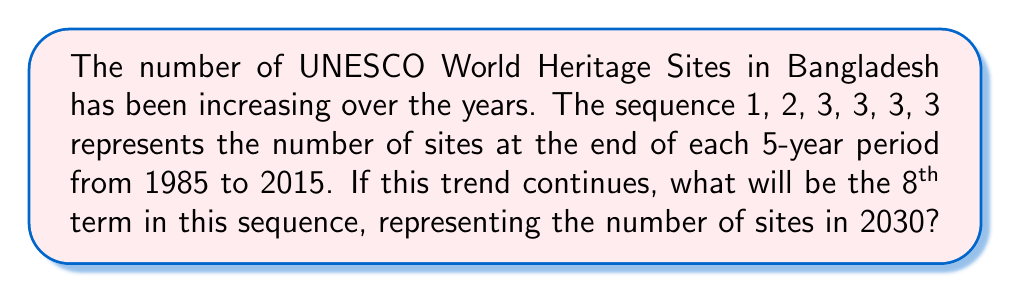Give your solution to this math problem. Let's analyze the sequence step-by-step:

1) The given sequence is: 1, 2, 3, 3, 3, 3

2) We can see that:
   - In 1985-1990: 1 site
   - In 1990-1995: 2 sites
   - In 1995-2000: 3 sites
   - In 2000-2005: 3 sites
   - In 2005-2010: 3 sites
   - In 2010-2015: 3 sites

3) We observe that the number of sites increased initially and then remained constant at 3 for four consecutive terms.

4) Assuming this trend continues, we can expect the number to remain at 3 for the next two terms:
   - 7th term (2015-2020): 3 sites
   - 8th term (2020-2025): 3 sites

5) Therefore, the 8th term in the sequence, representing the number of UNESCO World Heritage Sites in Bangladesh in 2030, would be 3.

This analysis assumes no new sites are added between 2015 and 2030, which is consistent with the observed trend from 1995 to 2015.
Answer: 3 